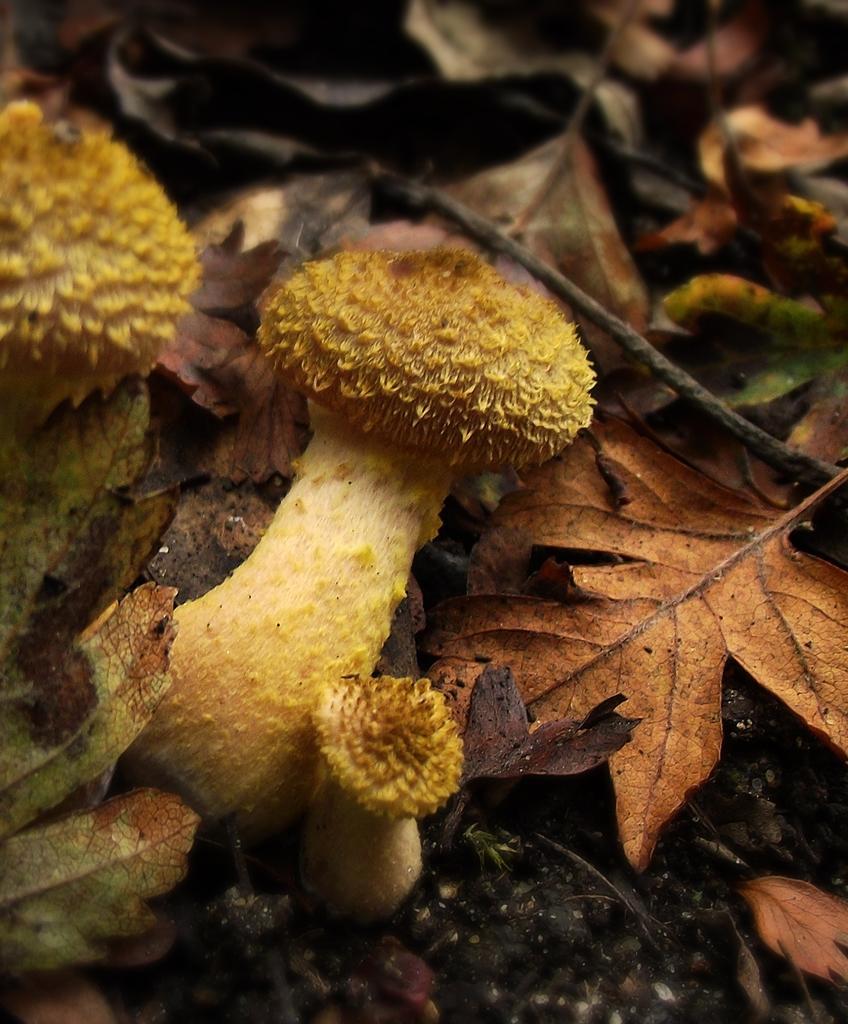Could you give a brief overview of what you see in this image? In this image, we can see mushrooms and some dried leaves. 